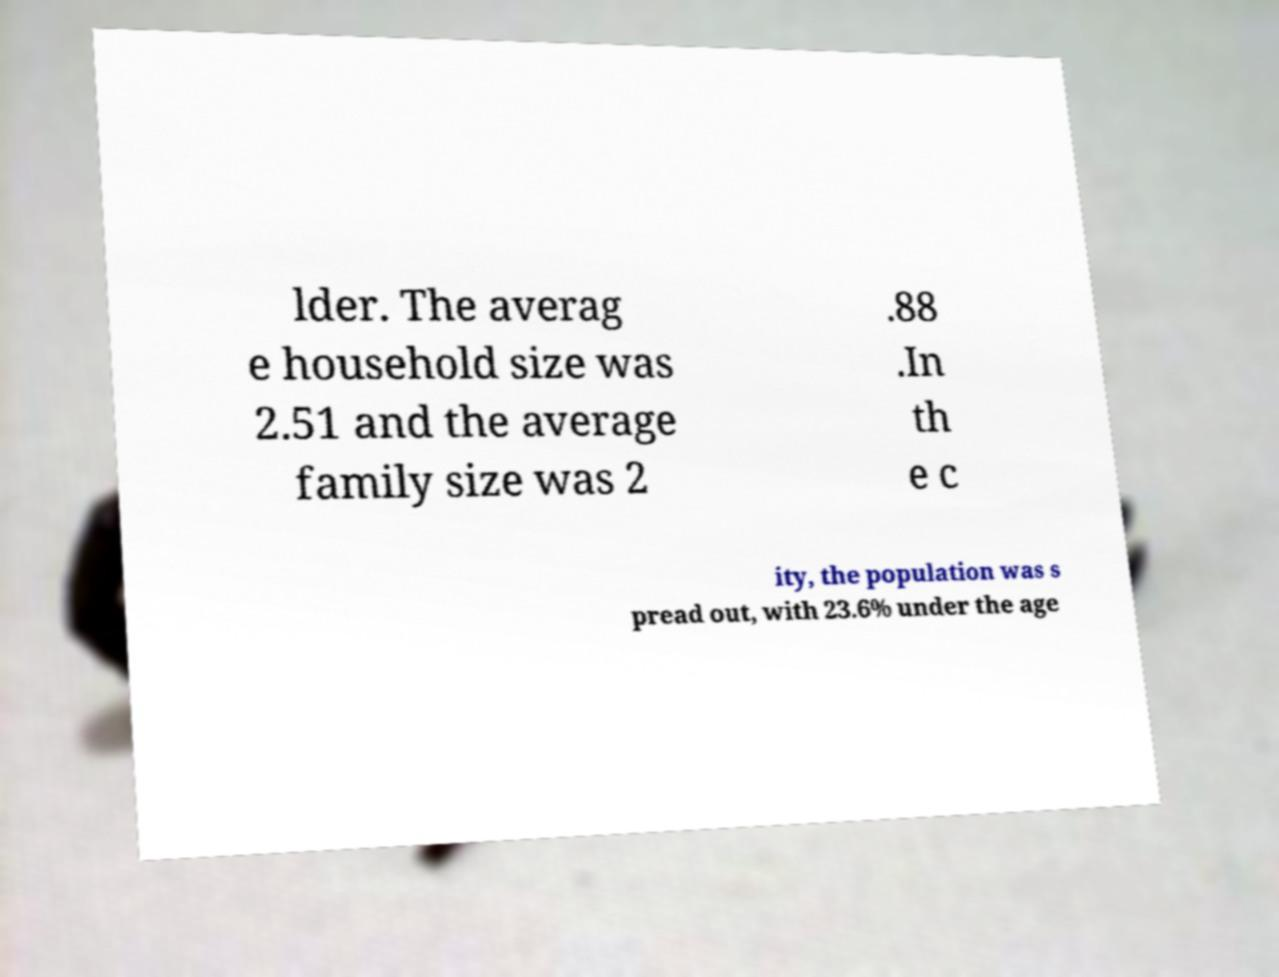There's text embedded in this image that I need extracted. Can you transcribe it verbatim? lder. The averag e household size was 2.51 and the average family size was 2 .88 .In th e c ity, the population was s pread out, with 23.6% under the age 